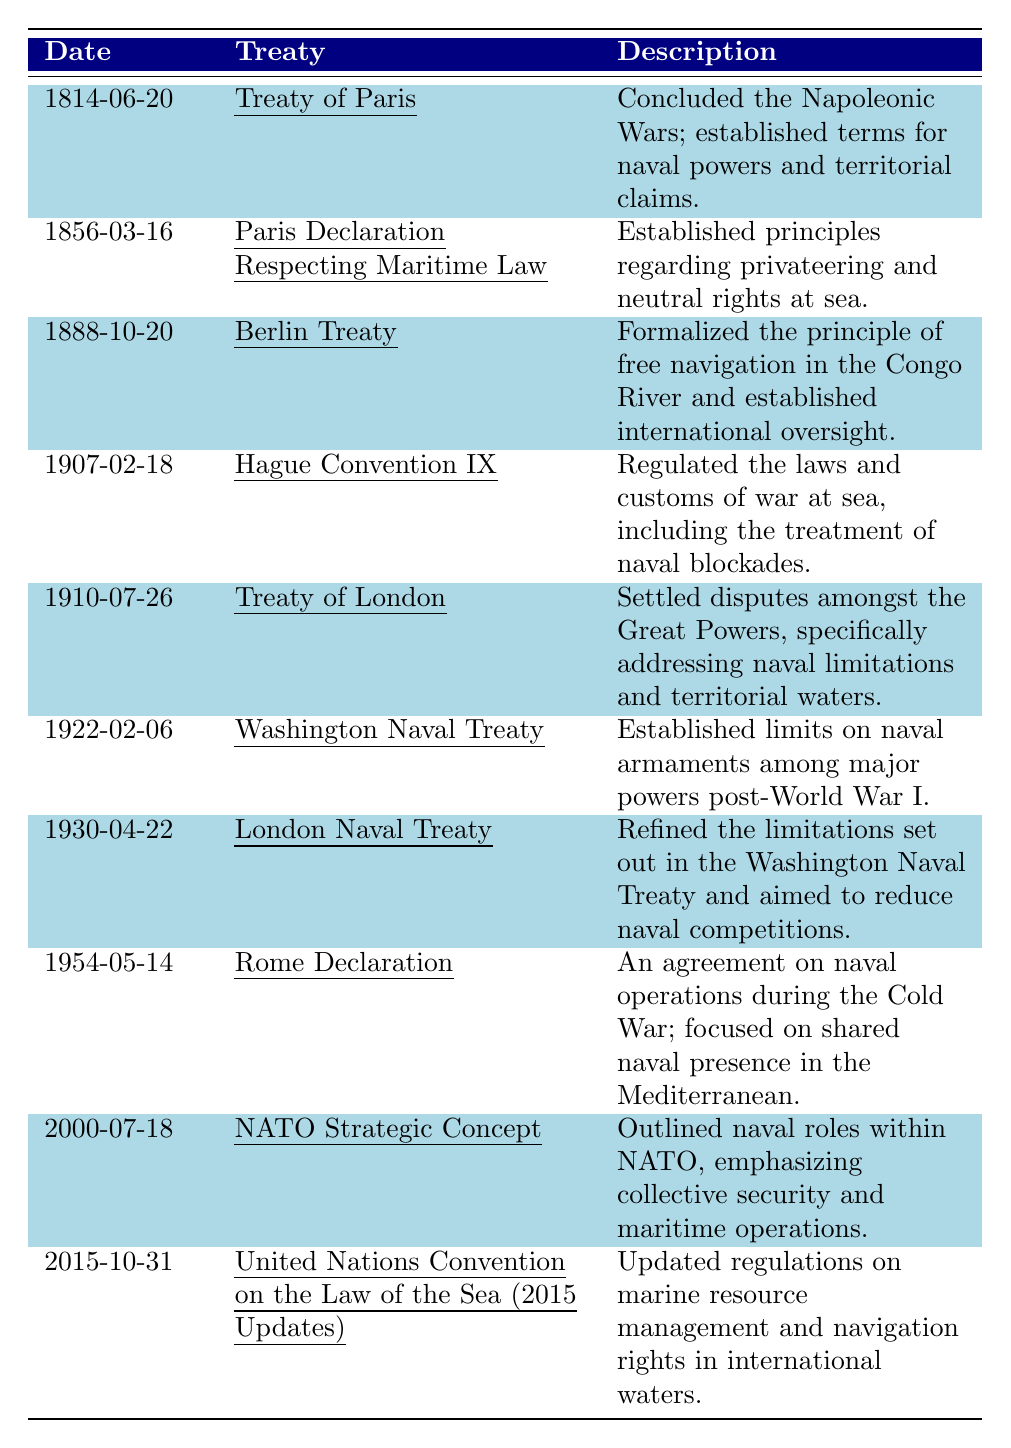What date was the Treaty of Paris signed? The table lists the Treaty of Paris with the date 1814-06-20.
Answer: 1814-06-20 What is the primary focus of the Washington Naval Treaty? The description for the Washington Naval Treaty states that it established limits on naval armaments among major powers post-World War I.
Answer: Limits on naval armaments Which treaty followed the London Naval Treaty? The table shows that the Rome Declaration was signed in 1954, which comes after the London Naval Treaty signed in 1930.
Answer: Rome Declaration How many treaties were signed in the 20th century? By counting the treaties listed in the table from 1900 to 1999, we find six treaties: Hague Convention IX, Treaty of London, Washington Naval Treaty, London Naval Treaty, Rome Declaration, and NATO Strategic Concept.
Answer: Six treaties Did the Berlin Treaty establish free navigation in the Congo River? The description for the Berlin Treaty indicates that it formalized the principle of free navigation in the Congo River.
Answer: Yes Which treaty was concerned with privateering and neutral rights at sea? The table lists the Paris Declaration Respecting Maritime Law, which established principles regarding privateering and neutral rights.
Answer: Paris Declaration Respecting Maritime Law What is the difference in years between the Treaty of Paris and the NATO Strategic Concept? The Treaty of Paris was signed in 1814 and the NATO Strategic Concept in 2000. The difference is 2000 - 1814 = 186 years.
Answer: 186 years Which treaty addressed naval presence in the Mediterranean during the Cold War? The Rome Declaration is specifically mentioned in the description as focusing on shared naval presence in the Mediterranean during the Cold War.
Answer: Rome Declaration What is the trend in maritime treaties from 1814 to 2015? Analyzing the table, there is a development from treaties focusing on naval conflicts and limitations to those addressing broader maritime laws and resource management regulations in international waters.
Answer: Development towards broader maritime laws How many treaties were signed after World War I? The table includes the Washington Naval Treaty (1922), London Naval Treaty (1930), Rome Declaration (1954), NATO Strategic Concept (2000), and United Nations Convention updates (2015), totaling five treaties after World War I.
Answer: Five treaties 